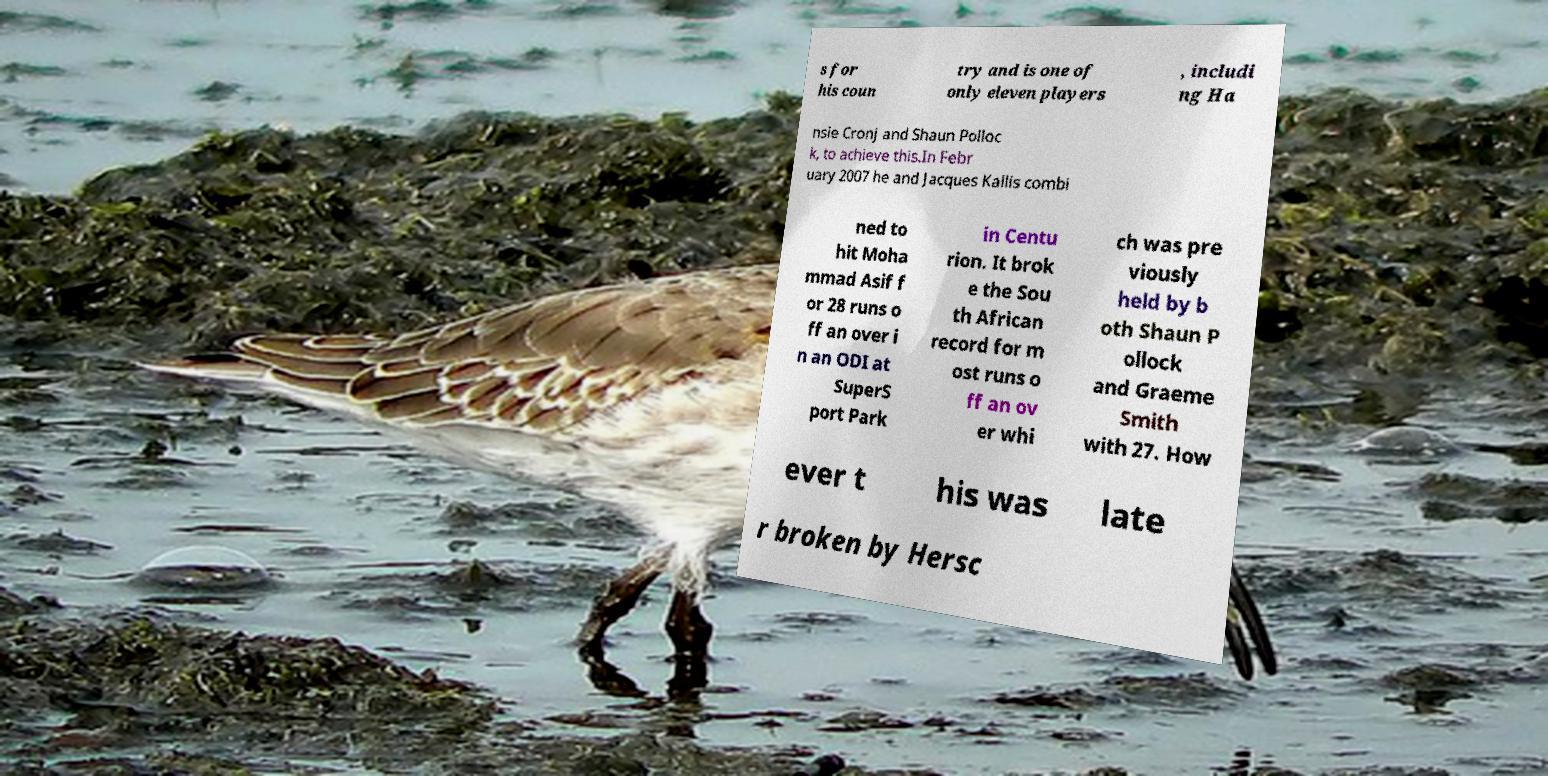Please identify and transcribe the text found in this image. s for his coun try and is one of only eleven players , includi ng Ha nsie Cronj and Shaun Polloc k, to achieve this.In Febr uary 2007 he and Jacques Kallis combi ned to hit Moha mmad Asif f or 28 runs o ff an over i n an ODI at SuperS port Park in Centu rion. It brok e the Sou th African record for m ost runs o ff an ov er whi ch was pre viously held by b oth Shaun P ollock and Graeme Smith with 27. How ever t his was late r broken by Hersc 